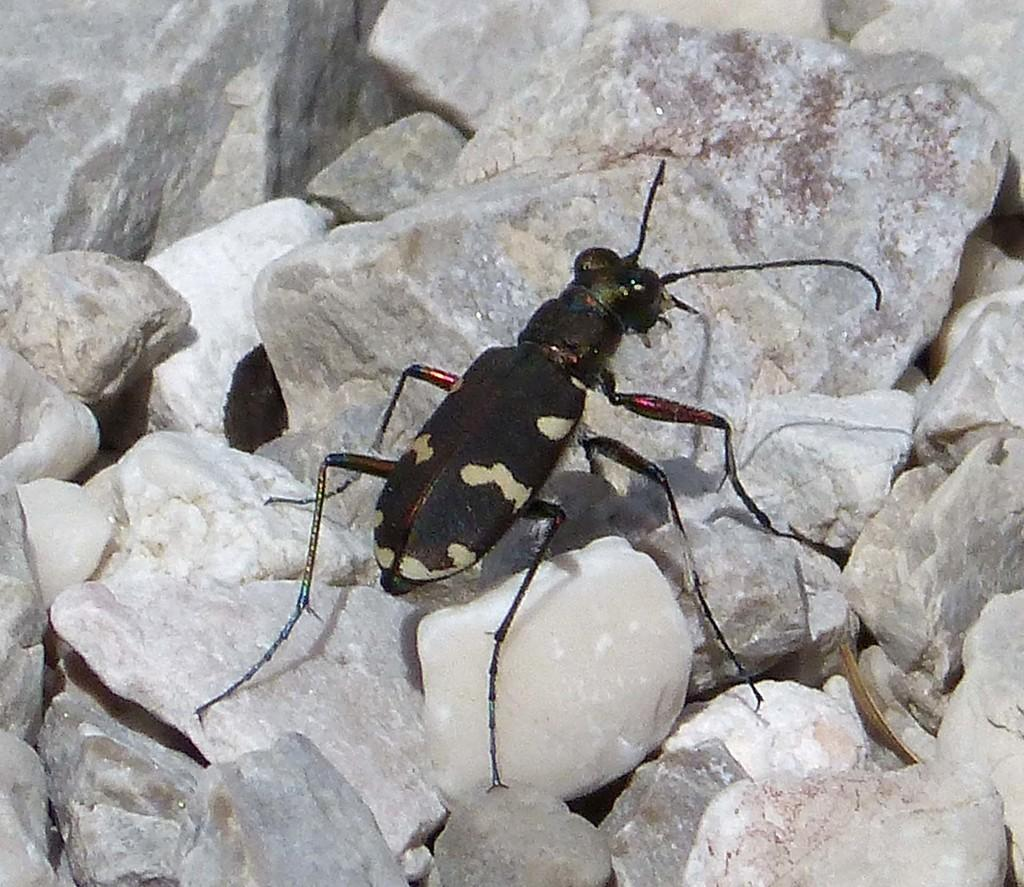What type of insect is in the image? There is a tiger beetle in the image. What color is the tiger beetle? The tiger beetle is black in color. What else can be seen in the image besides the tiger beetle? There are rocks in the image. What type of tax is being discussed in the image? There is no discussion of tax in the image; it features a tiger beetle and rocks. What surprise is depicted in the image? There is no surprise depicted in the image; it simply shows a black tiger beetle and rocks. 